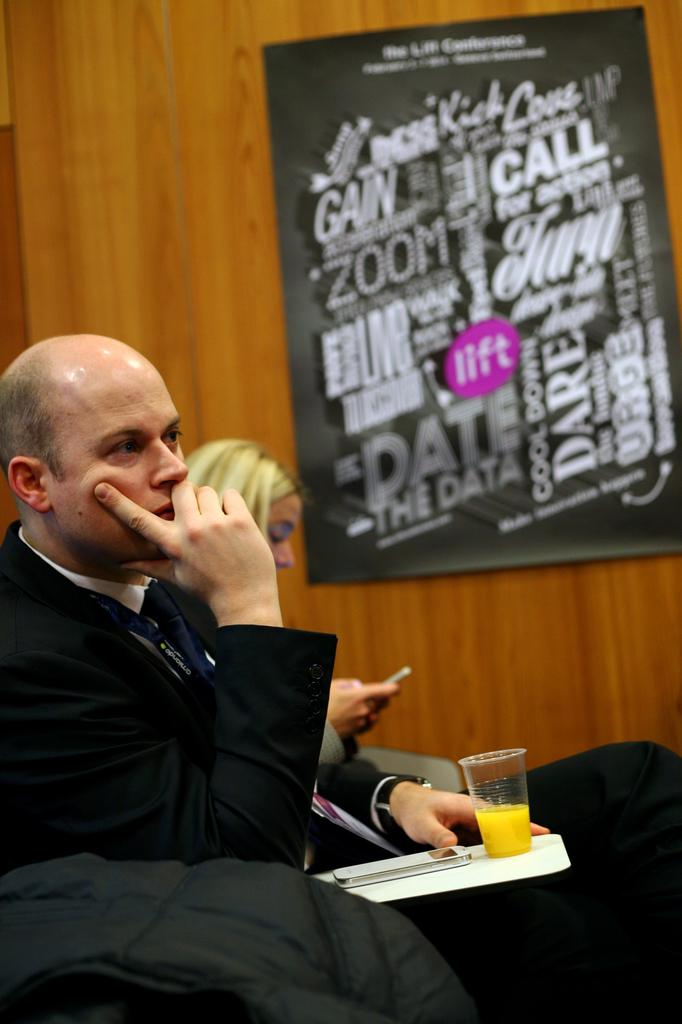Provide a one-sentence caption for the provided image. A man sitting with a cup of orange juice is in front of a poster with words such as GAIN an CALL. 